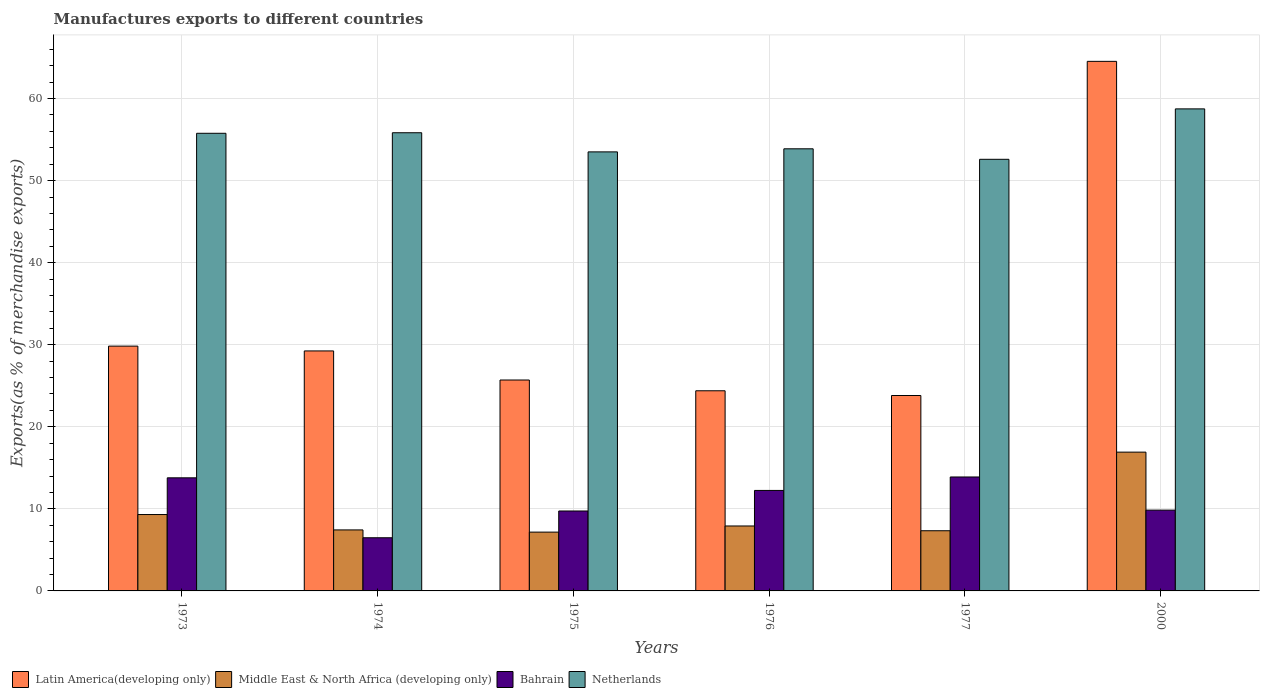Are the number of bars per tick equal to the number of legend labels?
Your answer should be very brief. Yes. How many bars are there on the 3rd tick from the right?
Ensure brevity in your answer.  4. What is the label of the 4th group of bars from the left?
Keep it short and to the point. 1976. In how many cases, is the number of bars for a given year not equal to the number of legend labels?
Provide a short and direct response. 0. What is the percentage of exports to different countries in Netherlands in 1973?
Offer a very short reply. 55.77. Across all years, what is the maximum percentage of exports to different countries in Netherlands?
Offer a very short reply. 58.74. Across all years, what is the minimum percentage of exports to different countries in Latin America(developing only)?
Offer a very short reply. 23.81. In which year was the percentage of exports to different countries in Bahrain maximum?
Your answer should be compact. 1977. In which year was the percentage of exports to different countries in Middle East & North Africa (developing only) minimum?
Make the answer very short. 1975. What is the total percentage of exports to different countries in Bahrain in the graph?
Provide a succinct answer. 65.98. What is the difference between the percentage of exports to different countries in Bahrain in 1974 and that in 1975?
Provide a succinct answer. -3.26. What is the difference between the percentage of exports to different countries in Middle East & North Africa (developing only) in 1975 and the percentage of exports to different countries in Netherlands in 1976?
Your answer should be compact. -46.71. What is the average percentage of exports to different countries in Latin America(developing only) per year?
Keep it short and to the point. 32.92. In the year 1975, what is the difference between the percentage of exports to different countries in Netherlands and percentage of exports to different countries in Latin America(developing only)?
Your answer should be compact. 27.8. What is the ratio of the percentage of exports to different countries in Bahrain in 1974 to that in 1975?
Provide a short and direct response. 0.67. What is the difference between the highest and the second highest percentage of exports to different countries in Bahrain?
Ensure brevity in your answer.  0.1. What is the difference between the highest and the lowest percentage of exports to different countries in Middle East & North Africa (developing only)?
Offer a very short reply. 9.75. In how many years, is the percentage of exports to different countries in Bahrain greater than the average percentage of exports to different countries in Bahrain taken over all years?
Your answer should be very brief. 3. Is it the case that in every year, the sum of the percentage of exports to different countries in Middle East & North Africa (developing only) and percentage of exports to different countries in Bahrain is greater than the sum of percentage of exports to different countries in Latin America(developing only) and percentage of exports to different countries in Netherlands?
Offer a very short reply. No. What does the 3rd bar from the left in 1977 represents?
Ensure brevity in your answer.  Bahrain. Is it the case that in every year, the sum of the percentage of exports to different countries in Netherlands and percentage of exports to different countries in Bahrain is greater than the percentage of exports to different countries in Latin America(developing only)?
Your response must be concise. Yes. What is the difference between two consecutive major ticks on the Y-axis?
Provide a succinct answer. 10. Are the values on the major ticks of Y-axis written in scientific E-notation?
Your answer should be compact. No. Does the graph contain any zero values?
Provide a short and direct response. No. What is the title of the graph?
Offer a very short reply. Manufactures exports to different countries. Does "Ukraine" appear as one of the legend labels in the graph?
Offer a terse response. No. What is the label or title of the Y-axis?
Your answer should be very brief. Exports(as % of merchandise exports). What is the Exports(as % of merchandise exports) in Latin America(developing only) in 1973?
Provide a short and direct response. 29.83. What is the Exports(as % of merchandise exports) in Middle East & North Africa (developing only) in 1973?
Your answer should be very brief. 9.31. What is the Exports(as % of merchandise exports) in Bahrain in 1973?
Your response must be concise. 13.78. What is the Exports(as % of merchandise exports) of Netherlands in 1973?
Make the answer very short. 55.77. What is the Exports(as % of merchandise exports) of Latin America(developing only) in 1974?
Provide a succinct answer. 29.24. What is the Exports(as % of merchandise exports) in Middle East & North Africa (developing only) in 1974?
Your response must be concise. 7.43. What is the Exports(as % of merchandise exports) of Bahrain in 1974?
Provide a short and direct response. 6.48. What is the Exports(as % of merchandise exports) in Netherlands in 1974?
Your response must be concise. 55.83. What is the Exports(as % of merchandise exports) in Latin America(developing only) in 1975?
Your response must be concise. 25.7. What is the Exports(as % of merchandise exports) of Middle East & North Africa (developing only) in 1975?
Your answer should be compact. 7.17. What is the Exports(as % of merchandise exports) in Bahrain in 1975?
Provide a short and direct response. 9.74. What is the Exports(as % of merchandise exports) of Netherlands in 1975?
Ensure brevity in your answer.  53.5. What is the Exports(as % of merchandise exports) in Latin America(developing only) in 1976?
Offer a very short reply. 24.39. What is the Exports(as % of merchandise exports) of Middle East & North Africa (developing only) in 1976?
Your response must be concise. 7.91. What is the Exports(as % of merchandise exports) of Bahrain in 1976?
Your response must be concise. 12.25. What is the Exports(as % of merchandise exports) in Netherlands in 1976?
Keep it short and to the point. 53.88. What is the Exports(as % of merchandise exports) of Latin America(developing only) in 1977?
Offer a terse response. 23.81. What is the Exports(as % of merchandise exports) in Middle East & North Africa (developing only) in 1977?
Provide a succinct answer. 7.33. What is the Exports(as % of merchandise exports) of Bahrain in 1977?
Give a very brief answer. 13.89. What is the Exports(as % of merchandise exports) in Netherlands in 1977?
Keep it short and to the point. 52.6. What is the Exports(as % of merchandise exports) of Latin America(developing only) in 2000?
Ensure brevity in your answer.  64.53. What is the Exports(as % of merchandise exports) of Middle East & North Africa (developing only) in 2000?
Ensure brevity in your answer.  16.91. What is the Exports(as % of merchandise exports) in Bahrain in 2000?
Ensure brevity in your answer.  9.85. What is the Exports(as % of merchandise exports) in Netherlands in 2000?
Your answer should be compact. 58.74. Across all years, what is the maximum Exports(as % of merchandise exports) in Latin America(developing only)?
Your answer should be compact. 64.53. Across all years, what is the maximum Exports(as % of merchandise exports) in Middle East & North Africa (developing only)?
Ensure brevity in your answer.  16.91. Across all years, what is the maximum Exports(as % of merchandise exports) of Bahrain?
Give a very brief answer. 13.89. Across all years, what is the maximum Exports(as % of merchandise exports) in Netherlands?
Keep it short and to the point. 58.74. Across all years, what is the minimum Exports(as % of merchandise exports) in Latin America(developing only)?
Keep it short and to the point. 23.81. Across all years, what is the minimum Exports(as % of merchandise exports) in Middle East & North Africa (developing only)?
Your response must be concise. 7.17. Across all years, what is the minimum Exports(as % of merchandise exports) in Bahrain?
Provide a short and direct response. 6.48. Across all years, what is the minimum Exports(as % of merchandise exports) of Netherlands?
Ensure brevity in your answer.  52.6. What is the total Exports(as % of merchandise exports) of Latin America(developing only) in the graph?
Offer a terse response. 197.51. What is the total Exports(as % of merchandise exports) in Middle East & North Africa (developing only) in the graph?
Your response must be concise. 56.07. What is the total Exports(as % of merchandise exports) of Bahrain in the graph?
Your response must be concise. 65.98. What is the total Exports(as % of merchandise exports) of Netherlands in the graph?
Offer a very short reply. 330.31. What is the difference between the Exports(as % of merchandise exports) in Latin America(developing only) in 1973 and that in 1974?
Make the answer very short. 0.59. What is the difference between the Exports(as % of merchandise exports) of Middle East & North Africa (developing only) in 1973 and that in 1974?
Offer a very short reply. 1.87. What is the difference between the Exports(as % of merchandise exports) of Bahrain in 1973 and that in 1974?
Your answer should be compact. 7.3. What is the difference between the Exports(as % of merchandise exports) of Netherlands in 1973 and that in 1974?
Your answer should be very brief. -0.07. What is the difference between the Exports(as % of merchandise exports) of Latin America(developing only) in 1973 and that in 1975?
Offer a terse response. 4.13. What is the difference between the Exports(as % of merchandise exports) of Middle East & North Africa (developing only) in 1973 and that in 1975?
Provide a short and direct response. 2.14. What is the difference between the Exports(as % of merchandise exports) in Bahrain in 1973 and that in 1975?
Make the answer very short. 4.04. What is the difference between the Exports(as % of merchandise exports) in Netherlands in 1973 and that in 1975?
Offer a terse response. 2.26. What is the difference between the Exports(as % of merchandise exports) in Latin America(developing only) in 1973 and that in 1976?
Offer a terse response. 5.44. What is the difference between the Exports(as % of merchandise exports) of Middle East & North Africa (developing only) in 1973 and that in 1976?
Provide a short and direct response. 1.39. What is the difference between the Exports(as % of merchandise exports) in Bahrain in 1973 and that in 1976?
Keep it short and to the point. 1.54. What is the difference between the Exports(as % of merchandise exports) of Netherlands in 1973 and that in 1976?
Ensure brevity in your answer.  1.89. What is the difference between the Exports(as % of merchandise exports) of Latin America(developing only) in 1973 and that in 1977?
Your answer should be very brief. 6.02. What is the difference between the Exports(as % of merchandise exports) in Middle East & North Africa (developing only) in 1973 and that in 1977?
Ensure brevity in your answer.  1.97. What is the difference between the Exports(as % of merchandise exports) in Bahrain in 1973 and that in 1977?
Offer a very short reply. -0.1. What is the difference between the Exports(as % of merchandise exports) in Netherlands in 1973 and that in 1977?
Keep it short and to the point. 3.17. What is the difference between the Exports(as % of merchandise exports) of Latin America(developing only) in 1973 and that in 2000?
Make the answer very short. -34.7. What is the difference between the Exports(as % of merchandise exports) in Middle East & North Africa (developing only) in 1973 and that in 2000?
Keep it short and to the point. -7.6. What is the difference between the Exports(as % of merchandise exports) in Bahrain in 1973 and that in 2000?
Your answer should be compact. 3.94. What is the difference between the Exports(as % of merchandise exports) of Netherlands in 1973 and that in 2000?
Offer a very short reply. -2.97. What is the difference between the Exports(as % of merchandise exports) in Latin America(developing only) in 1974 and that in 1975?
Offer a terse response. 3.54. What is the difference between the Exports(as % of merchandise exports) of Middle East & North Africa (developing only) in 1974 and that in 1975?
Provide a short and direct response. 0.27. What is the difference between the Exports(as % of merchandise exports) of Bahrain in 1974 and that in 1975?
Ensure brevity in your answer.  -3.26. What is the difference between the Exports(as % of merchandise exports) of Netherlands in 1974 and that in 1975?
Provide a succinct answer. 2.33. What is the difference between the Exports(as % of merchandise exports) in Latin America(developing only) in 1974 and that in 1976?
Your response must be concise. 4.86. What is the difference between the Exports(as % of merchandise exports) in Middle East & North Africa (developing only) in 1974 and that in 1976?
Keep it short and to the point. -0.48. What is the difference between the Exports(as % of merchandise exports) of Bahrain in 1974 and that in 1976?
Offer a very short reply. -5.77. What is the difference between the Exports(as % of merchandise exports) of Netherlands in 1974 and that in 1976?
Give a very brief answer. 1.96. What is the difference between the Exports(as % of merchandise exports) of Latin America(developing only) in 1974 and that in 1977?
Offer a terse response. 5.43. What is the difference between the Exports(as % of merchandise exports) in Middle East & North Africa (developing only) in 1974 and that in 1977?
Make the answer very short. 0.1. What is the difference between the Exports(as % of merchandise exports) in Bahrain in 1974 and that in 1977?
Provide a short and direct response. -7.41. What is the difference between the Exports(as % of merchandise exports) of Netherlands in 1974 and that in 1977?
Your answer should be compact. 3.24. What is the difference between the Exports(as % of merchandise exports) in Latin America(developing only) in 1974 and that in 2000?
Make the answer very short. -35.29. What is the difference between the Exports(as % of merchandise exports) of Middle East & North Africa (developing only) in 1974 and that in 2000?
Offer a terse response. -9.48. What is the difference between the Exports(as % of merchandise exports) in Bahrain in 1974 and that in 2000?
Offer a very short reply. -3.37. What is the difference between the Exports(as % of merchandise exports) in Netherlands in 1974 and that in 2000?
Provide a succinct answer. -2.91. What is the difference between the Exports(as % of merchandise exports) in Latin America(developing only) in 1975 and that in 1976?
Ensure brevity in your answer.  1.31. What is the difference between the Exports(as % of merchandise exports) in Middle East & North Africa (developing only) in 1975 and that in 1976?
Your answer should be very brief. -0.75. What is the difference between the Exports(as % of merchandise exports) in Bahrain in 1975 and that in 1976?
Your answer should be very brief. -2.51. What is the difference between the Exports(as % of merchandise exports) of Netherlands in 1975 and that in 1976?
Offer a very short reply. -0.37. What is the difference between the Exports(as % of merchandise exports) in Latin America(developing only) in 1975 and that in 1977?
Offer a terse response. 1.89. What is the difference between the Exports(as % of merchandise exports) in Middle East & North Africa (developing only) in 1975 and that in 1977?
Provide a short and direct response. -0.17. What is the difference between the Exports(as % of merchandise exports) in Bahrain in 1975 and that in 1977?
Provide a succinct answer. -4.15. What is the difference between the Exports(as % of merchandise exports) in Netherlands in 1975 and that in 1977?
Provide a short and direct response. 0.91. What is the difference between the Exports(as % of merchandise exports) in Latin America(developing only) in 1975 and that in 2000?
Give a very brief answer. -38.83. What is the difference between the Exports(as % of merchandise exports) of Middle East & North Africa (developing only) in 1975 and that in 2000?
Your response must be concise. -9.75. What is the difference between the Exports(as % of merchandise exports) in Bahrain in 1975 and that in 2000?
Keep it short and to the point. -0.11. What is the difference between the Exports(as % of merchandise exports) in Netherlands in 1975 and that in 2000?
Make the answer very short. -5.24. What is the difference between the Exports(as % of merchandise exports) of Latin America(developing only) in 1976 and that in 1977?
Your answer should be very brief. 0.58. What is the difference between the Exports(as % of merchandise exports) in Middle East & North Africa (developing only) in 1976 and that in 1977?
Offer a very short reply. 0.58. What is the difference between the Exports(as % of merchandise exports) in Bahrain in 1976 and that in 1977?
Keep it short and to the point. -1.64. What is the difference between the Exports(as % of merchandise exports) of Netherlands in 1976 and that in 1977?
Offer a terse response. 1.28. What is the difference between the Exports(as % of merchandise exports) in Latin America(developing only) in 1976 and that in 2000?
Provide a succinct answer. -40.14. What is the difference between the Exports(as % of merchandise exports) of Middle East & North Africa (developing only) in 1976 and that in 2000?
Give a very brief answer. -9. What is the difference between the Exports(as % of merchandise exports) in Bahrain in 1976 and that in 2000?
Ensure brevity in your answer.  2.4. What is the difference between the Exports(as % of merchandise exports) in Netherlands in 1976 and that in 2000?
Keep it short and to the point. -4.86. What is the difference between the Exports(as % of merchandise exports) of Latin America(developing only) in 1977 and that in 2000?
Give a very brief answer. -40.72. What is the difference between the Exports(as % of merchandise exports) of Middle East & North Africa (developing only) in 1977 and that in 2000?
Provide a succinct answer. -9.58. What is the difference between the Exports(as % of merchandise exports) in Bahrain in 1977 and that in 2000?
Make the answer very short. 4.04. What is the difference between the Exports(as % of merchandise exports) of Netherlands in 1977 and that in 2000?
Your answer should be very brief. -6.14. What is the difference between the Exports(as % of merchandise exports) in Latin America(developing only) in 1973 and the Exports(as % of merchandise exports) in Middle East & North Africa (developing only) in 1974?
Make the answer very short. 22.4. What is the difference between the Exports(as % of merchandise exports) of Latin America(developing only) in 1973 and the Exports(as % of merchandise exports) of Bahrain in 1974?
Offer a very short reply. 23.35. What is the difference between the Exports(as % of merchandise exports) of Latin America(developing only) in 1973 and the Exports(as % of merchandise exports) of Netherlands in 1974?
Make the answer very short. -26. What is the difference between the Exports(as % of merchandise exports) of Middle East & North Africa (developing only) in 1973 and the Exports(as % of merchandise exports) of Bahrain in 1974?
Ensure brevity in your answer.  2.83. What is the difference between the Exports(as % of merchandise exports) in Middle East & North Africa (developing only) in 1973 and the Exports(as % of merchandise exports) in Netherlands in 1974?
Your answer should be compact. -46.52. What is the difference between the Exports(as % of merchandise exports) in Bahrain in 1973 and the Exports(as % of merchandise exports) in Netherlands in 1974?
Your response must be concise. -42.05. What is the difference between the Exports(as % of merchandise exports) of Latin America(developing only) in 1973 and the Exports(as % of merchandise exports) of Middle East & North Africa (developing only) in 1975?
Your response must be concise. 22.67. What is the difference between the Exports(as % of merchandise exports) in Latin America(developing only) in 1973 and the Exports(as % of merchandise exports) in Bahrain in 1975?
Give a very brief answer. 20.09. What is the difference between the Exports(as % of merchandise exports) of Latin America(developing only) in 1973 and the Exports(as % of merchandise exports) of Netherlands in 1975?
Provide a short and direct response. -23.67. What is the difference between the Exports(as % of merchandise exports) of Middle East & North Africa (developing only) in 1973 and the Exports(as % of merchandise exports) of Bahrain in 1975?
Offer a very short reply. -0.43. What is the difference between the Exports(as % of merchandise exports) in Middle East & North Africa (developing only) in 1973 and the Exports(as % of merchandise exports) in Netherlands in 1975?
Your answer should be very brief. -44.19. What is the difference between the Exports(as % of merchandise exports) in Bahrain in 1973 and the Exports(as % of merchandise exports) in Netherlands in 1975?
Make the answer very short. -39.72. What is the difference between the Exports(as % of merchandise exports) in Latin America(developing only) in 1973 and the Exports(as % of merchandise exports) in Middle East & North Africa (developing only) in 1976?
Keep it short and to the point. 21.92. What is the difference between the Exports(as % of merchandise exports) of Latin America(developing only) in 1973 and the Exports(as % of merchandise exports) of Bahrain in 1976?
Ensure brevity in your answer.  17.59. What is the difference between the Exports(as % of merchandise exports) in Latin America(developing only) in 1973 and the Exports(as % of merchandise exports) in Netherlands in 1976?
Provide a succinct answer. -24.04. What is the difference between the Exports(as % of merchandise exports) in Middle East & North Africa (developing only) in 1973 and the Exports(as % of merchandise exports) in Bahrain in 1976?
Your response must be concise. -2.94. What is the difference between the Exports(as % of merchandise exports) in Middle East & North Africa (developing only) in 1973 and the Exports(as % of merchandise exports) in Netherlands in 1976?
Provide a short and direct response. -44.57. What is the difference between the Exports(as % of merchandise exports) in Bahrain in 1973 and the Exports(as % of merchandise exports) in Netherlands in 1976?
Provide a short and direct response. -40.09. What is the difference between the Exports(as % of merchandise exports) of Latin America(developing only) in 1973 and the Exports(as % of merchandise exports) of Middle East & North Africa (developing only) in 1977?
Offer a very short reply. 22.5. What is the difference between the Exports(as % of merchandise exports) of Latin America(developing only) in 1973 and the Exports(as % of merchandise exports) of Bahrain in 1977?
Keep it short and to the point. 15.95. What is the difference between the Exports(as % of merchandise exports) of Latin America(developing only) in 1973 and the Exports(as % of merchandise exports) of Netherlands in 1977?
Offer a terse response. -22.76. What is the difference between the Exports(as % of merchandise exports) in Middle East & North Africa (developing only) in 1973 and the Exports(as % of merchandise exports) in Bahrain in 1977?
Provide a succinct answer. -4.58. What is the difference between the Exports(as % of merchandise exports) in Middle East & North Africa (developing only) in 1973 and the Exports(as % of merchandise exports) in Netherlands in 1977?
Offer a terse response. -43.29. What is the difference between the Exports(as % of merchandise exports) of Bahrain in 1973 and the Exports(as % of merchandise exports) of Netherlands in 1977?
Provide a succinct answer. -38.81. What is the difference between the Exports(as % of merchandise exports) in Latin America(developing only) in 1973 and the Exports(as % of merchandise exports) in Middle East & North Africa (developing only) in 2000?
Offer a very short reply. 12.92. What is the difference between the Exports(as % of merchandise exports) in Latin America(developing only) in 1973 and the Exports(as % of merchandise exports) in Bahrain in 2000?
Provide a succinct answer. 19.99. What is the difference between the Exports(as % of merchandise exports) of Latin America(developing only) in 1973 and the Exports(as % of merchandise exports) of Netherlands in 2000?
Make the answer very short. -28.91. What is the difference between the Exports(as % of merchandise exports) of Middle East & North Africa (developing only) in 1973 and the Exports(as % of merchandise exports) of Bahrain in 2000?
Your answer should be very brief. -0.54. What is the difference between the Exports(as % of merchandise exports) in Middle East & North Africa (developing only) in 1973 and the Exports(as % of merchandise exports) in Netherlands in 2000?
Ensure brevity in your answer.  -49.43. What is the difference between the Exports(as % of merchandise exports) of Bahrain in 1973 and the Exports(as % of merchandise exports) of Netherlands in 2000?
Ensure brevity in your answer.  -44.96. What is the difference between the Exports(as % of merchandise exports) of Latin America(developing only) in 1974 and the Exports(as % of merchandise exports) of Middle East & North Africa (developing only) in 1975?
Your response must be concise. 22.08. What is the difference between the Exports(as % of merchandise exports) in Latin America(developing only) in 1974 and the Exports(as % of merchandise exports) in Bahrain in 1975?
Offer a terse response. 19.51. What is the difference between the Exports(as % of merchandise exports) in Latin America(developing only) in 1974 and the Exports(as % of merchandise exports) in Netherlands in 1975?
Ensure brevity in your answer.  -24.26. What is the difference between the Exports(as % of merchandise exports) of Middle East & North Africa (developing only) in 1974 and the Exports(as % of merchandise exports) of Bahrain in 1975?
Provide a succinct answer. -2.31. What is the difference between the Exports(as % of merchandise exports) of Middle East & North Africa (developing only) in 1974 and the Exports(as % of merchandise exports) of Netherlands in 1975?
Make the answer very short. -46.07. What is the difference between the Exports(as % of merchandise exports) of Bahrain in 1974 and the Exports(as % of merchandise exports) of Netherlands in 1975?
Offer a terse response. -47.02. What is the difference between the Exports(as % of merchandise exports) of Latin America(developing only) in 1974 and the Exports(as % of merchandise exports) of Middle East & North Africa (developing only) in 1976?
Provide a succinct answer. 21.33. What is the difference between the Exports(as % of merchandise exports) of Latin America(developing only) in 1974 and the Exports(as % of merchandise exports) of Bahrain in 1976?
Keep it short and to the point. 17. What is the difference between the Exports(as % of merchandise exports) in Latin America(developing only) in 1974 and the Exports(as % of merchandise exports) in Netherlands in 1976?
Your answer should be very brief. -24.63. What is the difference between the Exports(as % of merchandise exports) in Middle East & North Africa (developing only) in 1974 and the Exports(as % of merchandise exports) in Bahrain in 1976?
Provide a succinct answer. -4.81. What is the difference between the Exports(as % of merchandise exports) of Middle East & North Africa (developing only) in 1974 and the Exports(as % of merchandise exports) of Netherlands in 1976?
Ensure brevity in your answer.  -46.44. What is the difference between the Exports(as % of merchandise exports) in Bahrain in 1974 and the Exports(as % of merchandise exports) in Netherlands in 1976?
Your answer should be very brief. -47.4. What is the difference between the Exports(as % of merchandise exports) in Latin America(developing only) in 1974 and the Exports(as % of merchandise exports) in Middle East & North Africa (developing only) in 1977?
Offer a terse response. 21.91. What is the difference between the Exports(as % of merchandise exports) in Latin America(developing only) in 1974 and the Exports(as % of merchandise exports) in Bahrain in 1977?
Ensure brevity in your answer.  15.36. What is the difference between the Exports(as % of merchandise exports) in Latin America(developing only) in 1974 and the Exports(as % of merchandise exports) in Netherlands in 1977?
Your answer should be compact. -23.35. What is the difference between the Exports(as % of merchandise exports) of Middle East & North Africa (developing only) in 1974 and the Exports(as % of merchandise exports) of Bahrain in 1977?
Offer a terse response. -6.45. What is the difference between the Exports(as % of merchandise exports) in Middle East & North Africa (developing only) in 1974 and the Exports(as % of merchandise exports) in Netherlands in 1977?
Your answer should be compact. -45.16. What is the difference between the Exports(as % of merchandise exports) of Bahrain in 1974 and the Exports(as % of merchandise exports) of Netherlands in 1977?
Your answer should be compact. -46.12. What is the difference between the Exports(as % of merchandise exports) of Latin America(developing only) in 1974 and the Exports(as % of merchandise exports) of Middle East & North Africa (developing only) in 2000?
Your answer should be very brief. 12.33. What is the difference between the Exports(as % of merchandise exports) of Latin America(developing only) in 1974 and the Exports(as % of merchandise exports) of Bahrain in 2000?
Make the answer very short. 19.4. What is the difference between the Exports(as % of merchandise exports) in Latin America(developing only) in 1974 and the Exports(as % of merchandise exports) in Netherlands in 2000?
Give a very brief answer. -29.5. What is the difference between the Exports(as % of merchandise exports) of Middle East & North Africa (developing only) in 1974 and the Exports(as % of merchandise exports) of Bahrain in 2000?
Your answer should be compact. -2.41. What is the difference between the Exports(as % of merchandise exports) of Middle East & North Africa (developing only) in 1974 and the Exports(as % of merchandise exports) of Netherlands in 2000?
Offer a very short reply. -51.31. What is the difference between the Exports(as % of merchandise exports) of Bahrain in 1974 and the Exports(as % of merchandise exports) of Netherlands in 2000?
Ensure brevity in your answer.  -52.26. What is the difference between the Exports(as % of merchandise exports) in Latin America(developing only) in 1975 and the Exports(as % of merchandise exports) in Middle East & North Africa (developing only) in 1976?
Provide a short and direct response. 17.79. What is the difference between the Exports(as % of merchandise exports) of Latin America(developing only) in 1975 and the Exports(as % of merchandise exports) of Bahrain in 1976?
Keep it short and to the point. 13.46. What is the difference between the Exports(as % of merchandise exports) in Latin America(developing only) in 1975 and the Exports(as % of merchandise exports) in Netherlands in 1976?
Your response must be concise. -28.18. What is the difference between the Exports(as % of merchandise exports) of Middle East & North Africa (developing only) in 1975 and the Exports(as % of merchandise exports) of Bahrain in 1976?
Offer a very short reply. -5.08. What is the difference between the Exports(as % of merchandise exports) in Middle East & North Africa (developing only) in 1975 and the Exports(as % of merchandise exports) in Netherlands in 1976?
Your response must be concise. -46.71. What is the difference between the Exports(as % of merchandise exports) in Bahrain in 1975 and the Exports(as % of merchandise exports) in Netherlands in 1976?
Provide a short and direct response. -44.14. What is the difference between the Exports(as % of merchandise exports) in Latin America(developing only) in 1975 and the Exports(as % of merchandise exports) in Middle East & North Africa (developing only) in 1977?
Your answer should be compact. 18.37. What is the difference between the Exports(as % of merchandise exports) of Latin America(developing only) in 1975 and the Exports(as % of merchandise exports) of Bahrain in 1977?
Offer a terse response. 11.81. What is the difference between the Exports(as % of merchandise exports) in Latin America(developing only) in 1975 and the Exports(as % of merchandise exports) in Netherlands in 1977?
Your answer should be very brief. -26.89. What is the difference between the Exports(as % of merchandise exports) in Middle East & North Africa (developing only) in 1975 and the Exports(as % of merchandise exports) in Bahrain in 1977?
Ensure brevity in your answer.  -6.72. What is the difference between the Exports(as % of merchandise exports) in Middle East & North Africa (developing only) in 1975 and the Exports(as % of merchandise exports) in Netherlands in 1977?
Ensure brevity in your answer.  -45.43. What is the difference between the Exports(as % of merchandise exports) in Bahrain in 1975 and the Exports(as % of merchandise exports) in Netherlands in 1977?
Offer a very short reply. -42.86. What is the difference between the Exports(as % of merchandise exports) of Latin America(developing only) in 1975 and the Exports(as % of merchandise exports) of Middle East & North Africa (developing only) in 2000?
Provide a succinct answer. 8.79. What is the difference between the Exports(as % of merchandise exports) of Latin America(developing only) in 1975 and the Exports(as % of merchandise exports) of Bahrain in 2000?
Your answer should be very brief. 15.85. What is the difference between the Exports(as % of merchandise exports) in Latin America(developing only) in 1975 and the Exports(as % of merchandise exports) in Netherlands in 2000?
Your answer should be compact. -33.04. What is the difference between the Exports(as % of merchandise exports) of Middle East & North Africa (developing only) in 1975 and the Exports(as % of merchandise exports) of Bahrain in 2000?
Offer a terse response. -2.68. What is the difference between the Exports(as % of merchandise exports) of Middle East & North Africa (developing only) in 1975 and the Exports(as % of merchandise exports) of Netherlands in 2000?
Your answer should be very brief. -51.57. What is the difference between the Exports(as % of merchandise exports) of Bahrain in 1975 and the Exports(as % of merchandise exports) of Netherlands in 2000?
Your response must be concise. -49. What is the difference between the Exports(as % of merchandise exports) of Latin America(developing only) in 1976 and the Exports(as % of merchandise exports) of Middle East & North Africa (developing only) in 1977?
Offer a very short reply. 17.06. What is the difference between the Exports(as % of merchandise exports) of Latin America(developing only) in 1976 and the Exports(as % of merchandise exports) of Bahrain in 1977?
Ensure brevity in your answer.  10.5. What is the difference between the Exports(as % of merchandise exports) of Latin America(developing only) in 1976 and the Exports(as % of merchandise exports) of Netherlands in 1977?
Give a very brief answer. -28.21. What is the difference between the Exports(as % of merchandise exports) of Middle East & North Africa (developing only) in 1976 and the Exports(as % of merchandise exports) of Bahrain in 1977?
Give a very brief answer. -5.97. What is the difference between the Exports(as % of merchandise exports) in Middle East & North Africa (developing only) in 1976 and the Exports(as % of merchandise exports) in Netherlands in 1977?
Make the answer very short. -44.68. What is the difference between the Exports(as % of merchandise exports) in Bahrain in 1976 and the Exports(as % of merchandise exports) in Netherlands in 1977?
Make the answer very short. -40.35. What is the difference between the Exports(as % of merchandise exports) of Latin America(developing only) in 1976 and the Exports(as % of merchandise exports) of Middle East & North Africa (developing only) in 2000?
Ensure brevity in your answer.  7.48. What is the difference between the Exports(as % of merchandise exports) in Latin America(developing only) in 1976 and the Exports(as % of merchandise exports) in Bahrain in 2000?
Your response must be concise. 14.54. What is the difference between the Exports(as % of merchandise exports) of Latin America(developing only) in 1976 and the Exports(as % of merchandise exports) of Netherlands in 2000?
Offer a very short reply. -34.35. What is the difference between the Exports(as % of merchandise exports) of Middle East & North Africa (developing only) in 1976 and the Exports(as % of merchandise exports) of Bahrain in 2000?
Provide a short and direct response. -1.93. What is the difference between the Exports(as % of merchandise exports) of Middle East & North Africa (developing only) in 1976 and the Exports(as % of merchandise exports) of Netherlands in 2000?
Offer a very short reply. -50.83. What is the difference between the Exports(as % of merchandise exports) of Bahrain in 1976 and the Exports(as % of merchandise exports) of Netherlands in 2000?
Keep it short and to the point. -46.49. What is the difference between the Exports(as % of merchandise exports) of Latin America(developing only) in 1977 and the Exports(as % of merchandise exports) of Middle East & North Africa (developing only) in 2000?
Provide a short and direct response. 6.9. What is the difference between the Exports(as % of merchandise exports) in Latin America(developing only) in 1977 and the Exports(as % of merchandise exports) in Bahrain in 2000?
Your answer should be very brief. 13.97. What is the difference between the Exports(as % of merchandise exports) of Latin America(developing only) in 1977 and the Exports(as % of merchandise exports) of Netherlands in 2000?
Provide a succinct answer. -34.93. What is the difference between the Exports(as % of merchandise exports) in Middle East & North Africa (developing only) in 1977 and the Exports(as % of merchandise exports) in Bahrain in 2000?
Provide a succinct answer. -2.51. What is the difference between the Exports(as % of merchandise exports) in Middle East & North Africa (developing only) in 1977 and the Exports(as % of merchandise exports) in Netherlands in 2000?
Keep it short and to the point. -51.41. What is the difference between the Exports(as % of merchandise exports) in Bahrain in 1977 and the Exports(as % of merchandise exports) in Netherlands in 2000?
Offer a very short reply. -44.85. What is the average Exports(as % of merchandise exports) of Latin America(developing only) per year?
Your answer should be very brief. 32.92. What is the average Exports(as % of merchandise exports) in Middle East & North Africa (developing only) per year?
Make the answer very short. 9.34. What is the average Exports(as % of merchandise exports) in Bahrain per year?
Offer a very short reply. 11. What is the average Exports(as % of merchandise exports) of Netherlands per year?
Keep it short and to the point. 55.05. In the year 1973, what is the difference between the Exports(as % of merchandise exports) of Latin America(developing only) and Exports(as % of merchandise exports) of Middle East & North Africa (developing only)?
Provide a short and direct response. 20.52. In the year 1973, what is the difference between the Exports(as % of merchandise exports) of Latin America(developing only) and Exports(as % of merchandise exports) of Bahrain?
Provide a succinct answer. 16.05. In the year 1973, what is the difference between the Exports(as % of merchandise exports) in Latin America(developing only) and Exports(as % of merchandise exports) in Netherlands?
Provide a short and direct response. -25.93. In the year 1973, what is the difference between the Exports(as % of merchandise exports) of Middle East & North Africa (developing only) and Exports(as % of merchandise exports) of Bahrain?
Keep it short and to the point. -4.47. In the year 1973, what is the difference between the Exports(as % of merchandise exports) in Middle East & North Africa (developing only) and Exports(as % of merchandise exports) in Netherlands?
Offer a very short reply. -46.46. In the year 1973, what is the difference between the Exports(as % of merchandise exports) in Bahrain and Exports(as % of merchandise exports) in Netherlands?
Make the answer very short. -41.98. In the year 1974, what is the difference between the Exports(as % of merchandise exports) of Latin America(developing only) and Exports(as % of merchandise exports) of Middle East & North Africa (developing only)?
Your answer should be compact. 21.81. In the year 1974, what is the difference between the Exports(as % of merchandise exports) in Latin America(developing only) and Exports(as % of merchandise exports) in Bahrain?
Your answer should be very brief. 22.77. In the year 1974, what is the difference between the Exports(as % of merchandise exports) of Latin America(developing only) and Exports(as % of merchandise exports) of Netherlands?
Your answer should be compact. -26.59. In the year 1974, what is the difference between the Exports(as % of merchandise exports) of Middle East & North Africa (developing only) and Exports(as % of merchandise exports) of Bahrain?
Offer a very short reply. 0.95. In the year 1974, what is the difference between the Exports(as % of merchandise exports) of Middle East & North Africa (developing only) and Exports(as % of merchandise exports) of Netherlands?
Offer a very short reply. -48.4. In the year 1974, what is the difference between the Exports(as % of merchandise exports) of Bahrain and Exports(as % of merchandise exports) of Netherlands?
Make the answer very short. -49.35. In the year 1975, what is the difference between the Exports(as % of merchandise exports) of Latin America(developing only) and Exports(as % of merchandise exports) of Middle East & North Africa (developing only)?
Make the answer very short. 18.53. In the year 1975, what is the difference between the Exports(as % of merchandise exports) in Latin America(developing only) and Exports(as % of merchandise exports) in Bahrain?
Offer a terse response. 15.96. In the year 1975, what is the difference between the Exports(as % of merchandise exports) of Latin America(developing only) and Exports(as % of merchandise exports) of Netherlands?
Offer a terse response. -27.8. In the year 1975, what is the difference between the Exports(as % of merchandise exports) of Middle East & North Africa (developing only) and Exports(as % of merchandise exports) of Bahrain?
Keep it short and to the point. -2.57. In the year 1975, what is the difference between the Exports(as % of merchandise exports) in Middle East & North Africa (developing only) and Exports(as % of merchandise exports) in Netherlands?
Your answer should be compact. -46.34. In the year 1975, what is the difference between the Exports(as % of merchandise exports) in Bahrain and Exports(as % of merchandise exports) in Netherlands?
Give a very brief answer. -43.76. In the year 1976, what is the difference between the Exports(as % of merchandise exports) of Latin America(developing only) and Exports(as % of merchandise exports) of Middle East & North Africa (developing only)?
Your response must be concise. 16.48. In the year 1976, what is the difference between the Exports(as % of merchandise exports) in Latin America(developing only) and Exports(as % of merchandise exports) in Bahrain?
Offer a terse response. 12.14. In the year 1976, what is the difference between the Exports(as % of merchandise exports) in Latin America(developing only) and Exports(as % of merchandise exports) in Netherlands?
Provide a succinct answer. -29.49. In the year 1976, what is the difference between the Exports(as % of merchandise exports) of Middle East & North Africa (developing only) and Exports(as % of merchandise exports) of Bahrain?
Give a very brief answer. -4.33. In the year 1976, what is the difference between the Exports(as % of merchandise exports) of Middle East & North Africa (developing only) and Exports(as % of merchandise exports) of Netherlands?
Offer a terse response. -45.96. In the year 1976, what is the difference between the Exports(as % of merchandise exports) in Bahrain and Exports(as % of merchandise exports) in Netherlands?
Keep it short and to the point. -41.63. In the year 1977, what is the difference between the Exports(as % of merchandise exports) of Latin America(developing only) and Exports(as % of merchandise exports) of Middle East & North Africa (developing only)?
Ensure brevity in your answer.  16.48. In the year 1977, what is the difference between the Exports(as % of merchandise exports) in Latin America(developing only) and Exports(as % of merchandise exports) in Bahrain?
Ensure brevity in your answer.  9.93. In the year 1977, what is the difference between the Exports(as % of merchandise exports) of Latin America(developing only) and Exports(as % of merchandise exports) of Netherlands?
Your answer should be compact. -28.78. In the year 1977, what is the difference between the Exports(as % of merchandise exports) of Middle East & North Africa (developing only) and Exports(as % of merchandise exports) of Bahrain?
Ensure brevity in your answer.  -6.55. In the year 1977, what is the difference between the Exports(as % of merchandise exports) of Middle East & North Africa (developing only) and Exports(as % of merchandise exports) of Netherlands?
Your answer should be compact. -45.26. In the year 1977, what is the difference between the Exports(as % of merchandise exports) of Bahrain and Exports(as % of merchandise exports) of Netherlands?
Offer a very short reply. -38.71. In the year 2000, what is the difference between the Exports(as % of merchandise exports) of Latin America(developing only) and Exports(as % of merchandise exports) of Middle East & North Africa (developing only)?
Offer a very short reply. 47.62. In the year 2000, what is the difference between the Exports(as % of merchandise exports) of Latin America(developing only) and Exports(as % of merchandise exports) of Bahrain?
Provide a short and direct response. 54.69. In the year 2000, what is the difference between the Exports(as % of merchandise exports) of Latin America(developing only) and Exports(as % of merchandise exports) of Netherlands?
Your answer should be very brief. 5.79. In the year 2000, what is the difference between the Exports(as % of merchandise exports) in Middle East & North Africa (developing only) and Exports(as % of merchandise exports) in Bahrain?
Your answer should be very brief. 7.07. In the year 2000, what is the difference between the Exports(as % of merchandise exports) in Middle East & North Africa (developing only) and Exports(as % of merchandise exports) in Netherlands?
Your response must be concise. -41.83. In the year 2000, what is the difference between the Exports(as % of merchandise exports) in Bahrain and Exports(as % of merchandise exports) in Netherlands?
Make the answer very short. -48.89. What is the ratio of the Exports(as % of merchandise exports) of Latin America(developing only) in 1973 to that in 1974?
Offer a terse response. 1.02. What is the ratio of the Exports(as % of merchandise exports) of Middle East & North Africa (developing only) in 1973 to that in 1974?
Provide a succinct answer. 1.25. What is the ratio of the Exports(as % of merchandise exports) in Bahrain in 1973 to that in 1974?
Provide a succinct answer. 2.13. What is the ratio of the Exports(as % of merchandise exports) of Netherlands in 1973 to that in 1974?
Keep it short and to the point. 1. What is the ratio of the Exports(as % of merchandise exports) in Latin America(developing only) in 1973 to that in 1975?
Provide a short and direct response. 1.16. What is the ratio of the Exports(as % of merchandise exports) in Middle East & North Africa (developing only) in 1973 to that in 1975?
Your answer should be compact. 1.3. What is the ratio of the Exports(as % of merchandise exports) in Bahrain in 1973 to that in 1975?
Your answer should be compact. 1.42. What is the ratio of the Exports(as % of merchandise exports) in Netherlands in 1973 to that in 1975?
Your response must be concise. 1.04. What is the ratio of the Exports(as % of merchandise exports) of Latin America(developing only) in 1973 to that in 1976?
Your answer should be very brief. 1.22. What is the ratio of the Exports(as % of merchandise exports) in Middle East & North Africa (developing only) in 1973 to that in 1976?
Give a very brief answer. 1.18. What is the ratio of the Exports(as % of merchandise exports) of Bahrain in 1973 to that in 1976?
Give a very brief answer. 1.13. What is the ratio of the Exports(as % of merchandise exports) of Netherlands in 1973 to that in 1976?
Provide a short and direct response. 1.04. What is the ratio of the Exports(as % of merchandise exports) of Latin America(developing only) in 1973 to that in 1977?
Your response must be concise. 1.25. What is the ratio of the Exports(as % of merchandise exports) in Middle East & North Africa (developing only) in 1973 to that in 1977?
Give a very brief answer. 1.27. What is the ratio of the Exports(as % of merchandise exports) of Netherlands in 1973 to that in 1977?
Provide a succinct answer. 1.06. What is the ratio of the Exports(as % of merchandise exports) of Latin America(developing only) in 1973 to that in 2000?
Give a very brief answer. 0.46. What is the ratio of the Exports(as % of merchandise exports) of Middle East & North Africa (developing only) in 1973 to that in 2000?
Make the answer very short. 0.55. What is the ratio of the Exports(as % of merchandise exports) in Bahrain in 1973 to that in 2000?
Offer a terse response. 1.4. What is the ratio of the Exports(as % of merchandise exports) of Netherlands in 1973 to that in 2000?
Offer a terse response. 0.95. What is the ratio of the Exports(as % of merchandise exports) in Latin America(developing only) in 1974 to that in 1975?
Offer a very short reply. 1.14. What is the ratio of the Exports(as % of merchandise exports) of Middle East & North Africa (developing only) in 1974 to that in 1975?
Offer a very short reply. 1.04. What is the ratio of the Exports(as % of merchandise exports) in Bahrain in 1974 to that in 1975?
Your response must be concise. 0.67. What is the ratio of the Exports(as % of merchandise exports) of Netherlands in 1974 to that in 1975?
Offer a terse response. 1.04. What is the ratio of the Exports(as % of merchandise exports) in Latin America(developing only) in 1974 to that in 1976?
Ensure brevity in your answer.  1.2. What is the ratio of the Exports(as % of merchandise exports) in Middle East & North Africa (developing only) in 1974 to that in 1976?
Ensure brevity in your answer.  0.94. What is the ratio of the Exports(as % of merchandise exports) in Bahrain in 1974 to that in 1976?
Your answer should be very brief. 0.53. What is the ratio of the Exports(as % of merchandise exports) in Netherlands in 1974 to that in 1976?
Your response must be concise. 1.04. What is the ratio of the Exports(as % of merchandise exports) of Latin America(developing only) in 1974 to that in 1977?
Offer a very short reply. 1.23. What is the ratio of the Exports(as % of merchandise exports) in Middle East & North Africa (developing only) in 1974 to that in 1977?
Provide a succinct answer. 1.01. What is the ratio of the Exports(as % of merchandise exports) in Bahrain in 1974 to that in 1977?
Offer a terse response. 0.47. What is the ratio of the Exports(as % of merchandise exports) in Netherlands in 1974 to that in 1977?
Your response must be concise. 1.06. What is the ratio of the Exports(as % of merchandise exports) of Latin America(developing only) in 1974 to that in 2000?
Provide a short and direct response. 0.45. What is the ratio of the Exports(as % of merchandise exports) of Middle East & North Africa (developing only) in 1974 to that in 2000?
Offer a terse response. 0.44. What is the ratio of the Exports(as % of merchandise exports) in Bahrain in 1974 to that in 2000?
Keep it short and to the point. 0.66. What is the ratio of the Exports(as % of merchandise exports) of Netherlands in 1974 to that in 2000?
Your answer should be very brief. 0.95. What is the ratio of the Exports(as % of merchandise exports) in Latin America(developing only) in 1975 to that in 1976?
Offer a terse response. 1.05. What is the ratio of the Exports(as % of merchandise exports) in Middle East & North Africa (developing only) in 1975 to that in 1976?
Make the answer very short. 0.91. What is the ratio of the Exports(as % of merchandise exports) of Bahrain in 1975 to that in 1976?
Provide a short and direct response. 0.8. What is the ratio of the Exports(as % of merchandise exports) in Latin America(developing only) in 1975 to that in 1977?
Give a very brief answer. 1.08. What is the ratio of the Exports(as % of merchandise exports) of Middle East & North Africa (developing only) in 1975 to that in 1977?
Your answer should be very brief. 0.98. What is the ratio of the Exports(as % of merchandise exports) in Bahrain in 1975 to that in 1977?
Provide a succinct answer. 0.7. What is the ratio of the Exports(as % of merchandise exports) in Netherlands in 1975 to that in 1977?
Give a very brief answer. 1.02. What is the ratio of the Exports(as % of merchandise exports) of Latin America(developing only) in 1975 to that in 2000?
Provide a short and direct response. 0.4. What is the ratio of the Exports(as % of merchandise exports) of Middle East & North Africa (developing only) in 1975 to that in 2000?
Keep it short and to the point. 0.42. What is the ratio of the Exports(as % of merchandise exports) of Netherlands in 1975 to that in 2000?
Give a very brief answer. 0.91. What is the ratio of the Exports(as % of merchandise exports) of Latin America(developing only) in 1976 to that in 1977?
Offer a terse response. 1.02. What is the ratio of the Exports(as % of merchandise exports) of Middle East & North Africa (developing only) in 1976 to that in 1977?
Your answer should be very brief. 1.08. What is the ratio of the Exports(as % of merchandise exports) in Bahrain in 1976 to that in 1977?
Offer a terse response. 0.88. What is the ratio of the Exports(as % of merchandise exports) of Netherlands in 1976 to that in 1977?
Keep it short and to the point. 1.02. What is the ratio of the Exports(as % of merchandise exports) in Latin America(developing only) in 1976 to that in 2000?
Offer a very short reply. 0.38. What is the ratio of the Exports(as % of merchandise exports) in Middle East & North Africa (developing only) in 1976 to that in 2000?
Provide a short and direct response. 0.47. What is the ratio of the Exports(as % of merchandise exports) in Bahrain in 1976 to that in 2000?
Keep it short and to the point. 1.24. What is the ratio of the Exports(as % of merchandise exports) in Netherlands in 1976 to that in 2000?
Your answer should be very brief. 0.92. What is the ratio of the Exports(as % of merchandise exports) of Latin America(developing only) in 1977 to that in 2000?
Your answer should be very brief. 0.37. What is the ratio of the Exports(as % of merchandise exports) of Middle East & North Africa (developing only) in 1977 to that in 2000?
Keep it short and to the point. 0.43. What is the ratio of the Exports(as % of merchandise exports) of Bahrain in 1977 to that in 2000?
Provide a succinct answer. 1.41. What is the ratio of the Exports(as % of merchandise exports) in Netherlands in 1977 to that in 2000?
Keep it short and to the point. 0.9. What is the difference between the highest and the second highest Exports(as % of merchandise exports) of Latin America(developing only)?
Give a very brief answer. 34.7. What is the difference between the highest and the second highest Exports(as % of merchandise exports) in Middle East & North Africa (developing only)?
Ensure brevity in your answer.  7.6. What is the difference between the highest and the second highest Exports(as % of merchandise exports) in Bahrain?
Provide a short and direct response. 0.1. What is the difference between the highest and the second highest Exports(as % of merchandise exports) of Netherlands?
Offer a terse response. 2.91. What is the difference between the highest and the lowest Exports(as % of merchandise exports) of Latin America(developing only)?
Your response must be concise. 40.72. What is the difference between the highest and the lowest Exports(as % of merchandise exports) in Middle East & North Africa (developing only)?
Offer a terse response. 9.75. What is the difference between the highest and the lowest Exports(as % of merchandise exports) in Bahrain?
Provide a short and direct response. 7.41. What is the difference between the highest and the lowest Exports(as % of merchandise exports) of Netherlands?
Provide a short and direct response. 6.14. 